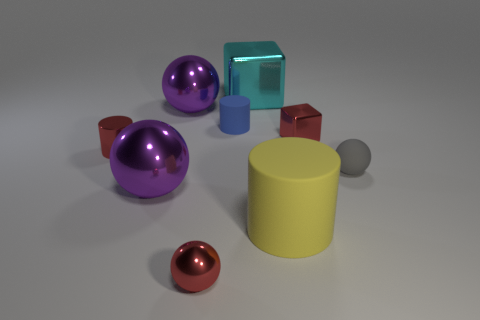What is the relative position of the purple object in relation to the blue and yellow objects? The purple object is positioned to the left of the yellow cylinder and in front of the blue cylinder when looking from the current perspective. 